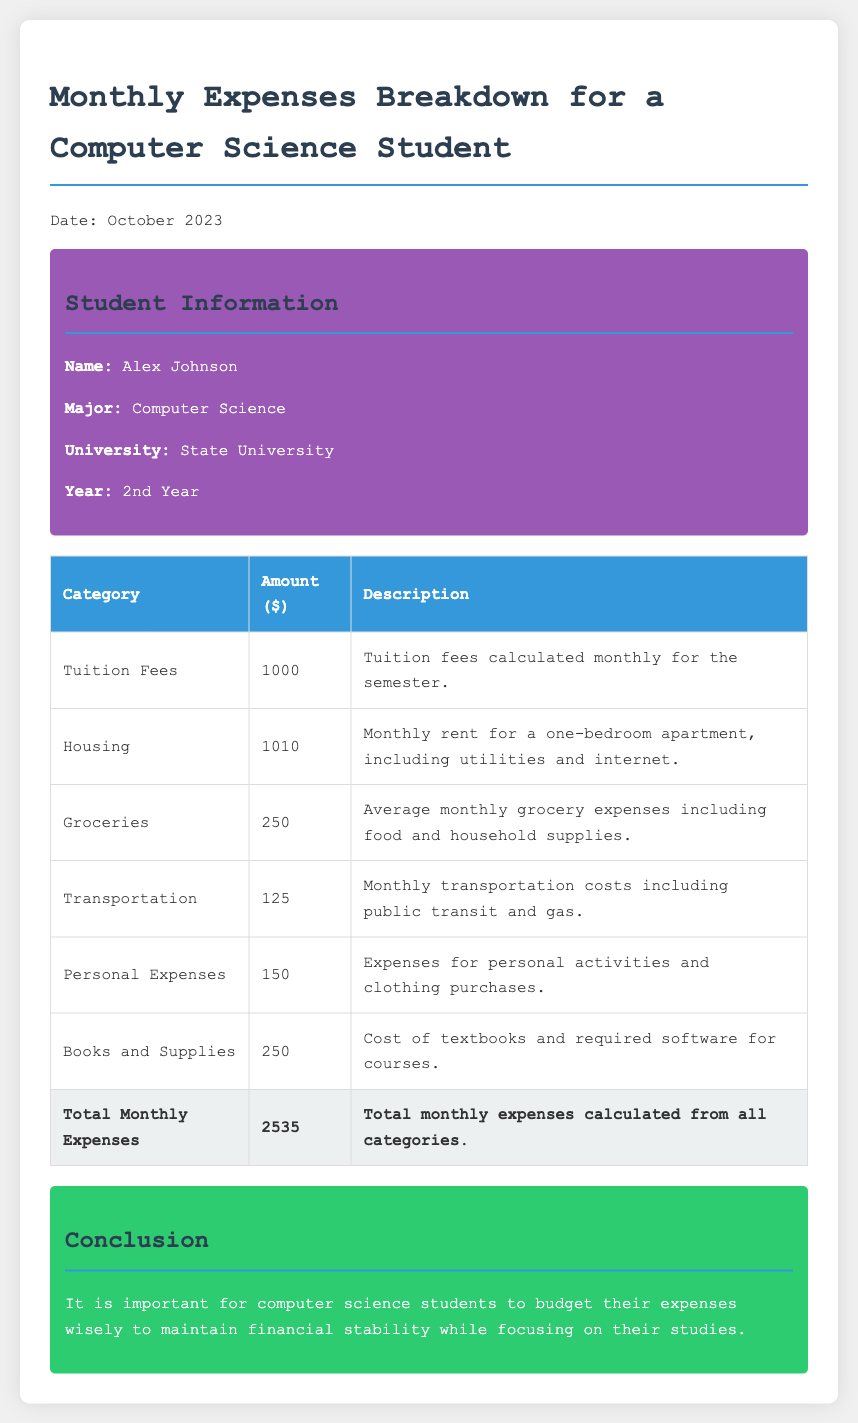What is the student's name? The student's name is mentioned in the student information section of the document.
Answer: Alex Johnson What is the total monthly expense? The total monthly expense is the sum of all the individual categories listed in the expenses table.
Answer: 2535 How much does the student spend on groceries? The amount spent on groceries is specified in the expenses table under the Groceries category.
Answer: 250 What category has the highest expense? The category with the highest expense can be identified by comparing the amounts listed in the expenses table.
Answer: Housing How much does the student pay for tuition fees? The tuition fees amount is provided in the document within the expenses table.
Answer: 1000 What is included in the transportation costs? The description for transportation costs outlines what is covered under this expense category.
Answer: Public transit and gas What is the purpose of this financial report? The report's purpose is indicated in the conclusion section, regarding budgeting awareness for students.
Answer: Budget expenses Which university is the student enrolled in? The university information is given in the student profile at the beginning of the document.
Answer: State University 